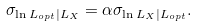<formula> <loc_0><loc_0><loc_500><loc_500>\sigma _ { \ln L _ { o p t } | L _ { X } } = \alpha \sigma _ { \ln L _ { X } | L _ { o p t } } .</formula> 